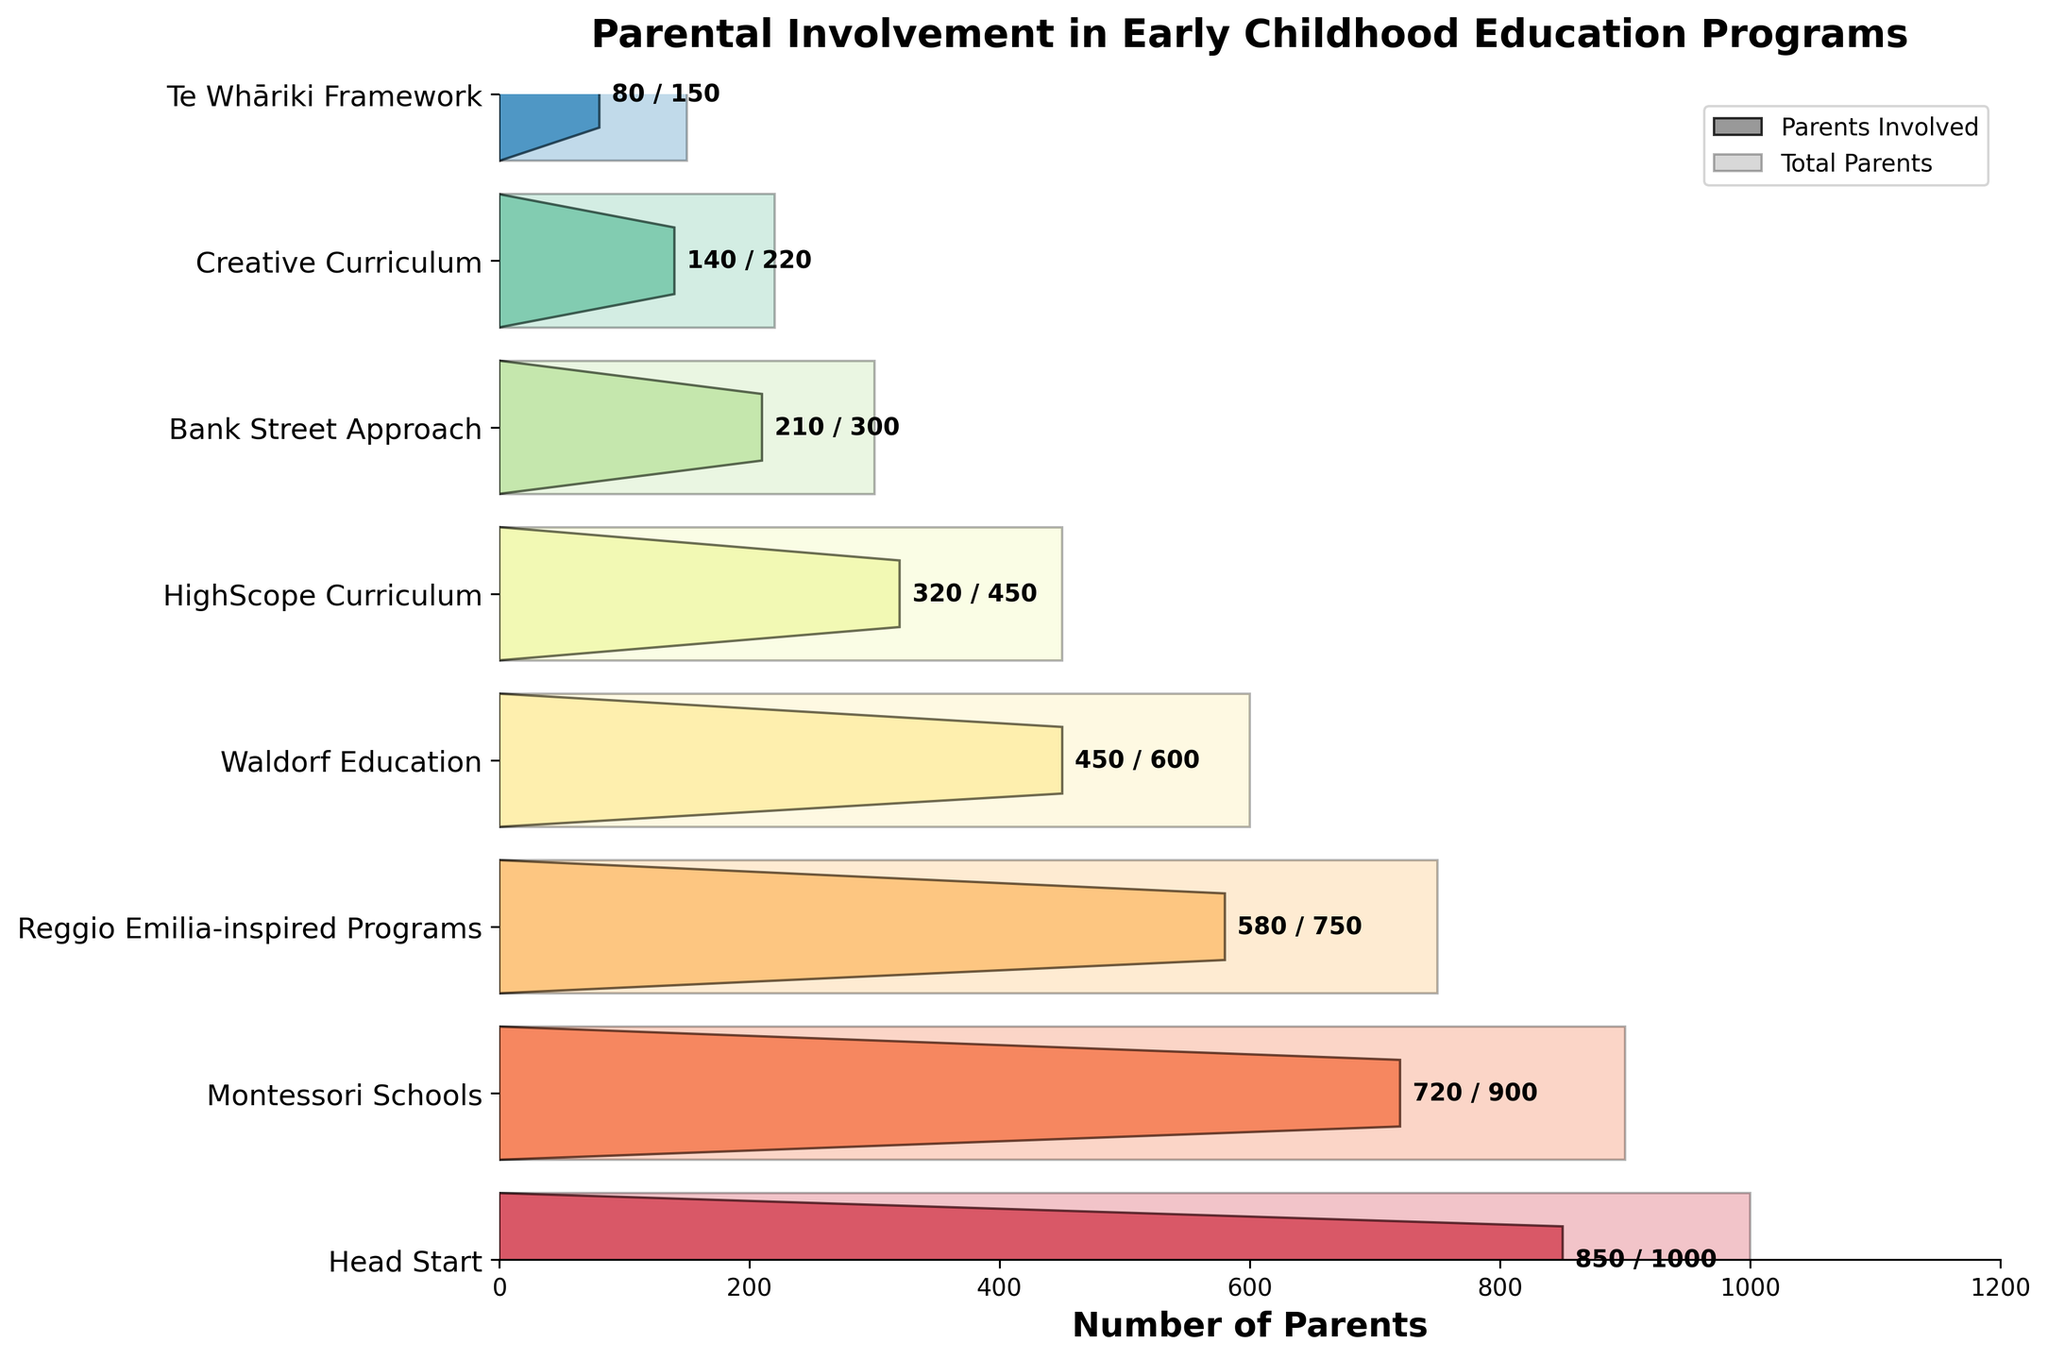What is the title of the figure? The title of the figure is typically located at the top and succinctly describes what the figure represents. By looking at the top of the figure, we can find the title "Parental Involvement in Early Childhood Education Programs".
Answer: Parental Involvement in Early Childhood Education Programs Which program has the highest number of parents involved? The highest number of parents involved can be identified by looking for the widest bar for "Parents Involved" on the plot. The figure shows that the "Head Start" program has the widest bar, indicating 850 parents involved.
Answer: Head Start How many total parents are there in the Te Whāriki Framework program? The total number of parents for a program can be identified by looking at the length of the lighter colored bars. For the "Te Whāriki Framework" program, the lighter bar extends to indicate 150 total parents.
Answer: 150 What is the difference between the total number of parents and the number of parents involved in the Waldorf Education program? This difference can be computed by subtracting the number of parents involved from the total number of parents for the Waldorf Education program. The total number of parents is 600 and the number involved is 450, thus the difference is 600 - 450.
Answer: 150 Which program has the smallest number of parents involved? The smallest number of parents involved can be identified by looking for the narrowest bar for "Parents Involved" on the plot. The figure shows that the "Te Whāriki Framework" program has the narrowest bar, indicating 80 parents involved.
Answer: Te Whāriki Framework What proportion of total parents are involved in the Montessori Schools program? To find the proportion, divide the number of involved parents by the total number of parents for the program and multiply by 100 to get a percentage. The involved parents are 720, and the total is 900, so the proportion is (720 / 900) * 100.
Answer: 80% Compare the number of parents involved in the Reggio Emilia-inspired Programs and the Bank Street Approach. Which program has more involved parents? To compare, look at the lengths of the "Parents Involved" bars for both programs. The Reggio Emilia-inspired Programs have 580 parents involved, while the Bank Street Approach has 210 parents involved. Therefore, Reggio Emilia-inspired Programs have more involved parents.
Answer: Reggio Emilia-inspired Programs Out of all the programs, what is the total sum of parents involved? To find the total sum, add up the numbers of parents involved from all the programs. This is 850 + 720 + 580 + 450 + 320 + 210 + 140 + 80.
Answer: 3350 Which program shows the largest gap between total parents and parents involved? To find the largest gap, calculate the differences for each program and identify the largest one. The differences are: Head Start (150), Montessori Schools (180), Reggio Emilia-inspired Programs (170), Waldorf Education (150), HighScope Curriculum (130), Bank Street Approach (90), Creative Curriculum (80), Te Whāriki Framework (70). The largest gap is for Montessori Schools.
Answer: Montessori Schools What percentage of total parents are involved across all programs? To find this percentage, first, sum the total parents and sum the parents involved across all programs, then divide the involved sum by the total sum and multiply by 100: Total involved = 3350, Total parents = 4370, Percentage = (3350 / 4370) * 100.
Answer: ~76.7% 